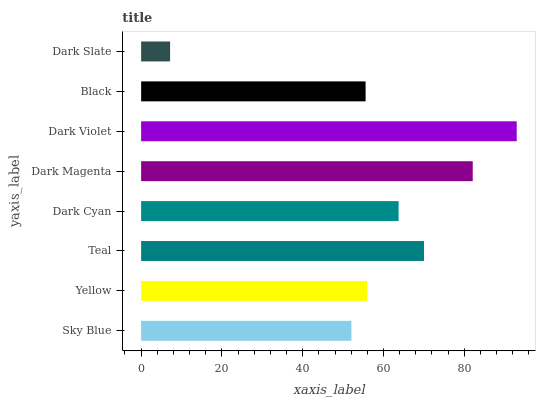Is Dark Slate the minimum?
Answer yes or no. Yes. Is Dark Violet the maximum?
Answer yes or no. Yes. Is Yellow the minimum?
Answer yes or no. No. Is Yellow the maximum?
Answer yes or no. No. Is Yellow greater than Sky Blue?
Answer yes or no. Yes. Is Sky Blue less than Yellow?
Answer yes or no. Yes. Is Sky Blue greater than Yellow?
Answer yes or no. No. Is Yellow less than Sky Blue?
Answer yes or no. No. Is Dark Cyan the high median?
Answer yes or no. Yes. Is Yellow the low median?
Answer yes or no. Yes. Is Sky Blue the high median?
Answer yes or no. No. Is Dark Violet the low median?
Answer yes or no. No. 